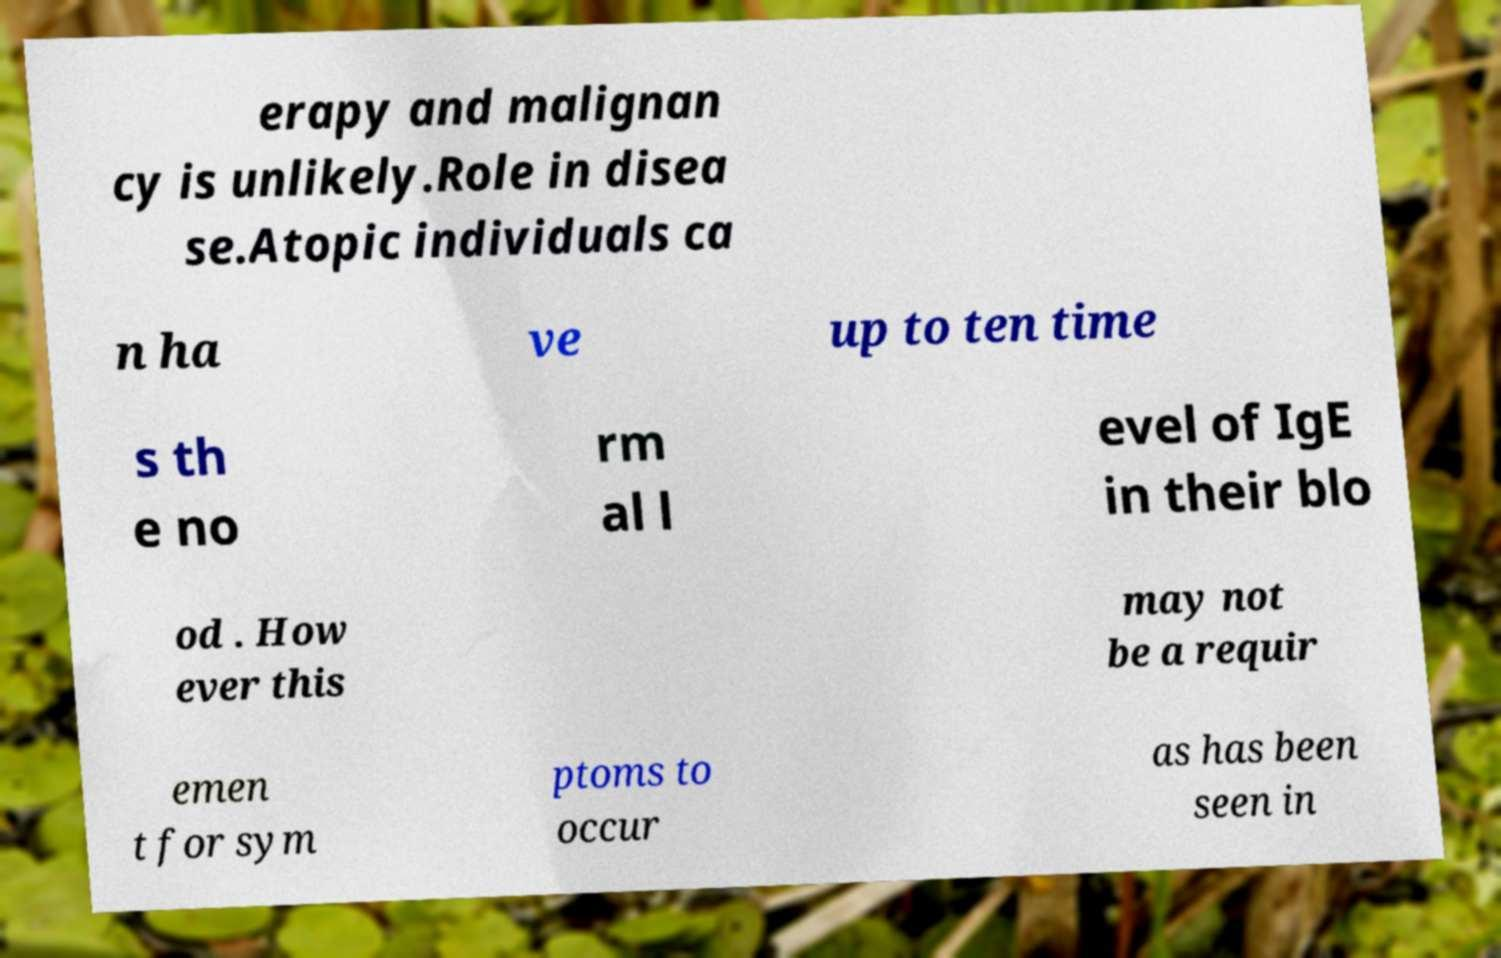Could you assist in decoding the text presented in this image and type it out clearly? erapy and malignan cy is unlikely.Role in disea se.Atopic individuals ca n ha ve up to ten time s th e no rm al l evel of IgE in their blo od . How ever this may not be a requir emen t for sym ptoms to occur as has been seen in 